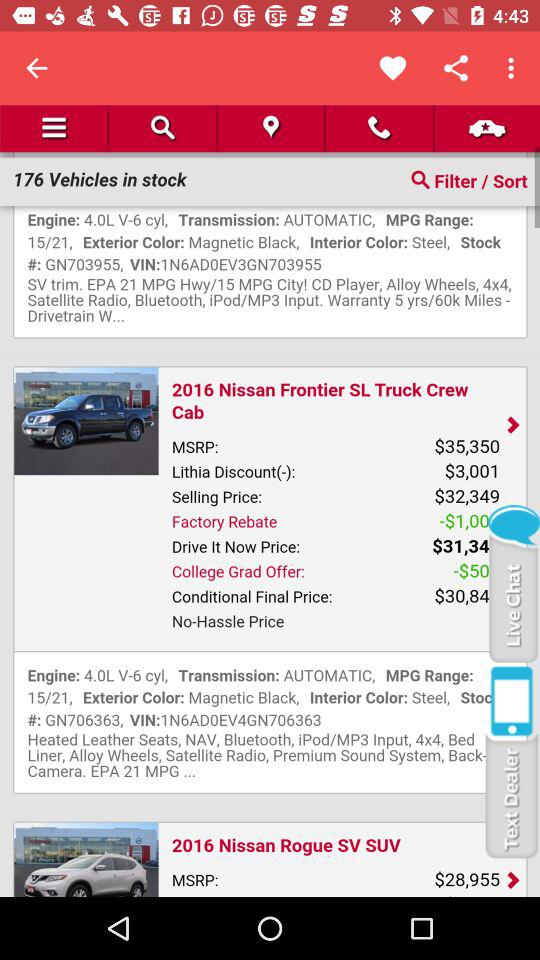What is the conditional final price of the "2016 Nissan Frontier SL Truck Crew Cab"? The conditional final price is "$30,84...". 